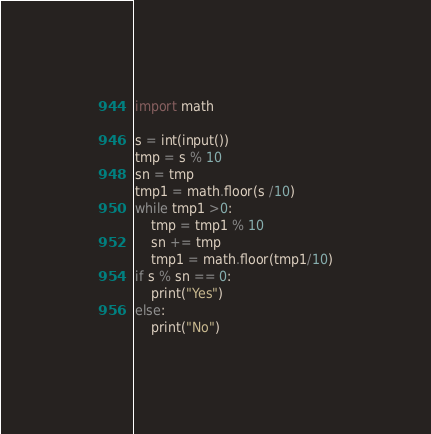<code> <loc_0><loc_0><loc_500><loc_500><_Python_>import math

s = int(input())
tmp = s % 10
sn = tmp
tmp1 = math.floor(s /10)
while tmp1 >0:
    tmp = tmp1 % 10
    sn += tmp
    tmp1 = math.floor(tmp1/10)
if s % sn == 0:
    print("Yes")
else:
    print("No")
</code> 